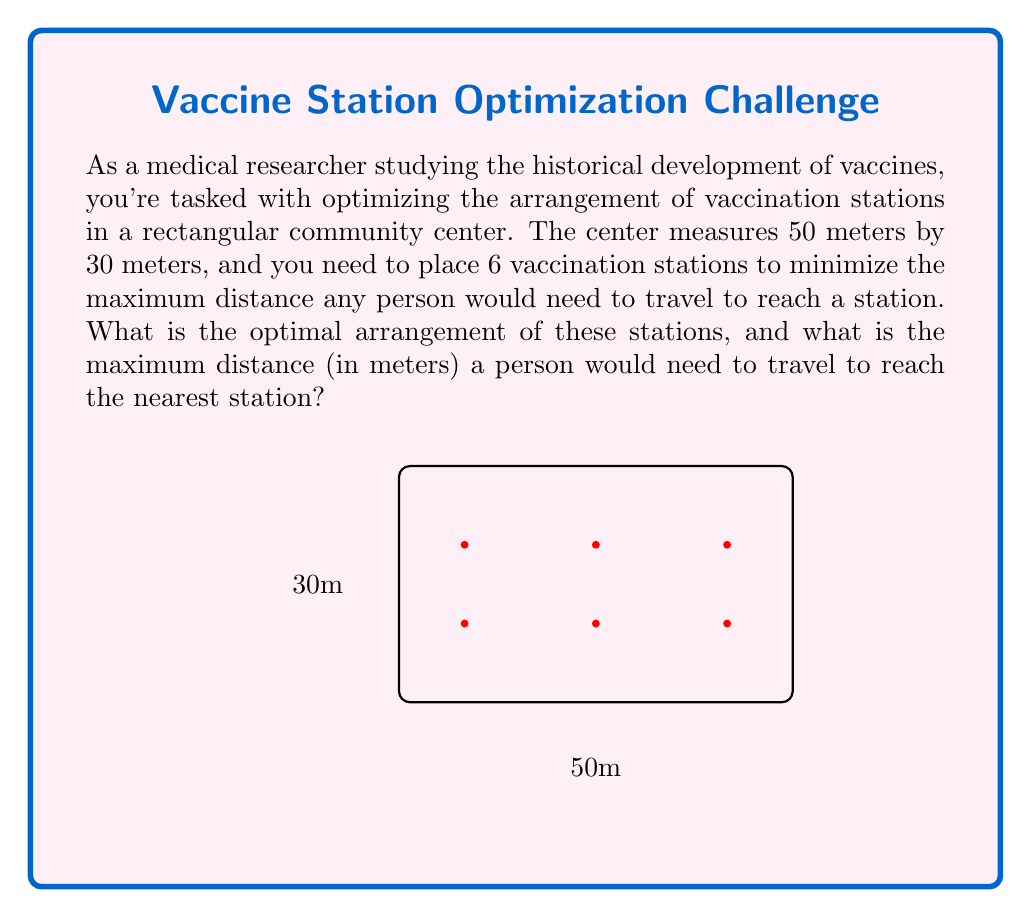Show me your answer to this math problem. To solve this problem, we can use the concept of Voronoi diagrams and the properties of hexagonal packing:

1) In an optimal arrangement, the area should be divided into equal parts, each served by one station.

2) The hexagonal packing theorem states that the most efficient way to cover a plane with equal circles is in a hexagonal pattern.

3) In our rectangular area, we can approximate this hexagonal pattern by arranging the stations in two rows of three.

4) To find the coordinates of the stations:
   - Divide the length (50m) into 3 equal parts: 50/3 ≈ 16.67m
   - Divide the width (30m) into 2 equal parts: 30/2 = 15m
   
5) The stations should be placed at:
   (8.33, 10), (25, 10), (41.67, 10)
   (8.33, 20), (25, 20), (41.67, 20)

6) In this arrangement, the maximum distance a person needs to travel is half the distance between two stations diagonally:

   $$d = \sqrt{(\frac{50}{3})^2 + 15^2} / 2 \approx 10.21$$

Therefore, the maximum distance is approximately 10.21 meters.
Answer: Two rows of three stations; max distance ≈ 10.21m 